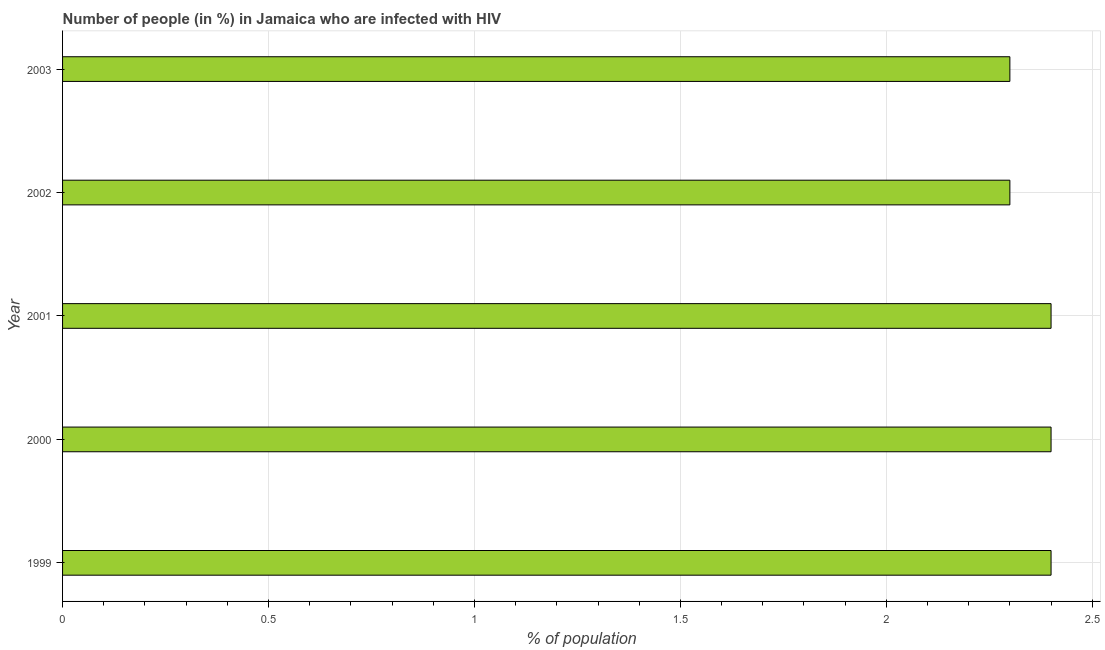What is the title of the graph?
Offer a terse response. Number of people (in %) in Jamaica who are infected with HIV. What is the label or title of the X-axis?
Offer a very short reply. % of population. What is the label or title of the Y-axis?
Your answer should be compact. Year. What is the number of people infected with hiv in 1999?
Offer a very short reply. 2.4. Across all years, what is the maximum number of people infected with hiv?
Make the answer very short. 2.4. Across all years, what is the minimum number of people infected with hiv?
Make the answer very short. 2.3. What is the difference between the number of people infected with hiv in 2000 and 2002?
Your answer should be compact. 0.1. What is the average number of people infected with hiv per year?
Give a very brief answer. 2.36. What is the median number of people infected with hiv?
Your answer should be compact. 2.4. What is the ratio of the number of people infected with hiv in 1999 to that in 2001?
Keep it short and to the point. 1. Is the number of people infected with hiv in 2000 less than that in 2003?
Make the answer very short. No. Is the difference between the number of people infected with hiv in 2000 and 2003 greater than the difference between any two years?
Provide a short and direct response. Yes. What is the difference between the highest and the second highest number of people infected with hiv?
Provide a succinct answer. 0. What is the difference between the highest and the lowest number of people infected with hiv?
Provide a short and direct response. 0.1. In how many years, is the number of people infected with hiv greater than the average number of people infected with hiv taken over all years?
Give a very brief answer. 3. How many bars are there?
Your response must be concise. 5. Are all the bars in the graph horizontal?
Your answer should be compact. Yes. How many years are there in the graph?
Your answer should be compact. 5. Are the values on the major ticks of X-axis written in scientific E-notation?
Provide a succinct answer. No. What is the % of population in 1999?
Provide a short and direct response. 2.4. What is the % of population in 2000?
Provide a short and direct response. 2.4. What is the % of population in 2002?
Make the answer very short. 2.3. What is the % of population of 2003?
Your response must be concise. 2.3. What is the difference between the % of population in 1999 and 2000?
Offer a very short reply. 0. What is the difference between the % of population in 1999 and 2001?
Ensure brevity in your answer.  0. What is the difference between the % of population in 1999 and 2002?
Provide a succinct answer. 0.1. What is the difference between the % of population in 2000 and 2002?
Ensure brevity in your answer.  0.1. What is the difference between the % of population in 2000 and 2003?
Your answer should be compact. 0.1. What is the difference between the % of population in 2001 and 2002?
Your answer should be very brief. 0.1. What is the difference between the % of population in 2001 and 2003?
Provide a succinct answer. 0.1. What is the ratio of the % of population in 1999 to that in 2002?
Provide a short and direct response. 1.04. What is the ratio of the % of population in 1999 to that in 2003?
Your answer should be very brief. 1.04. What is the ratio of the % of population in 2000 to that in 2001?
Make the answer very short. 1. What is the ratio of the % of population in 2000 to that in 2002?
Provide a short and direct response. 1.04. What is the ratio of the % of population in 2000 to that in 2003?
Ensure brevity in your answer.  1.04. What is the ratio of the % of population in 2001 to that in 2002?
Provide a succinct answer. 1.04. What is the ratio of the % of population in 2001 to that in 2003?
Keep it short and to the point. 1.04. 